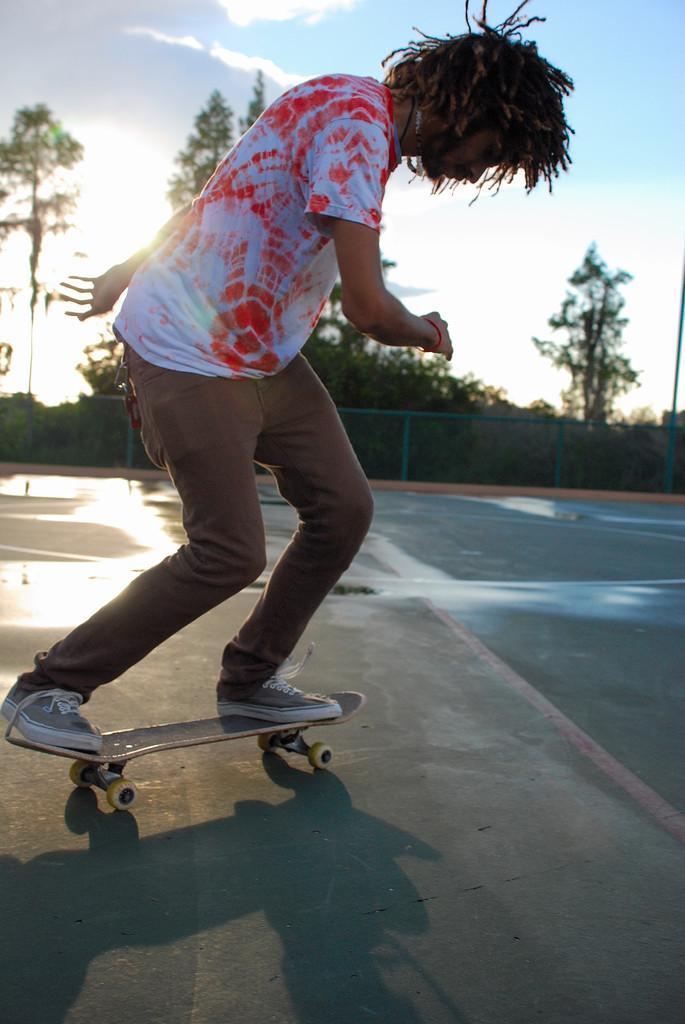In one or two sentences, can you explain what this image depicts? In this image there is a man skating on the ground. There is a skateboard below his legs. Behind him there is a fencing. In the background there are trees and plants. At the top there is the sky. 